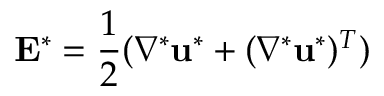<formula> <loc_0><loc_0><loc_500><loc_500>E ^ { * } = \frac { 1 } { 2 } ( \nabla ^ { * } u ^ { * } + ( \nabla ^ { * } u ^ { * } ) ^ { T } )</formula> 